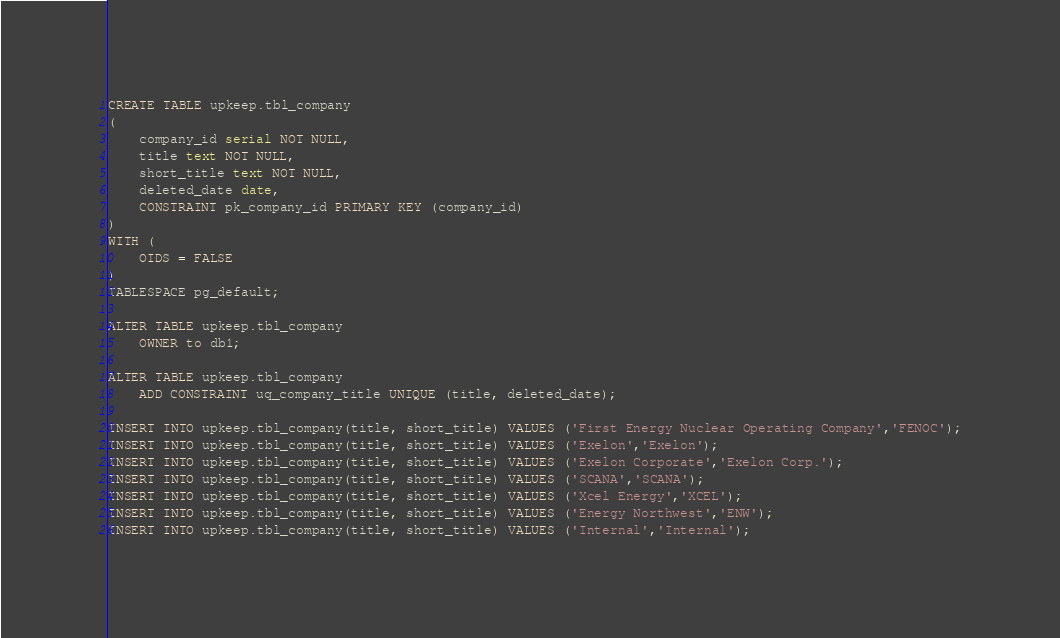<code> <loc_0><loc_0><loc_500><loc_500><_SQL_>CREATE TABLE upkeep.tbl_company
(
    company_id serial NOT NULL,
    title text NOT NULL,
    short_title text NOT NULL,
    deleted_date date,
    CONSTRAINT pk_company_id PRIMARY KEY (company_id)
)
WITH (
    OIDS = FALSE
)
TABLESPACE pg_default;

ALTER TABLE upkeep.tbl_company
    OWNER to db1;

ALTER TABLE upkeep.tbl_company
    ADD CONSTRAINT uq_company_title UNIQUE (title, deleted_date);

INSERT INTO upkeep.tbl_company(title, short_title) VALUES ('First Energy Nuclear Operating Company','FENOC');
INSERT INTO upkeep.tbl_company(title, short_title) VALUES ('Exelon','Exelon');
INSERT INTO upkeep.tbl_company(title, short_title) VALUES ('Exelon Corporate','Exelon Corp.');
INSERT INTO upkeep.tbl_company(title, short_title) VALUES ('SCANA','SCANA');
INSERT INTO upkeep.tbl_company(title, short_title) VALUES ('Xcel Energy','XCEL');
INSERT INTO upkeep.tbl_company(title, short_title) VALUES ('Energy Northwest','ENW');
INSERT INTO upkeep.tbl_company(title, short_title) VALUES ('Internal','Internal');
</code> 